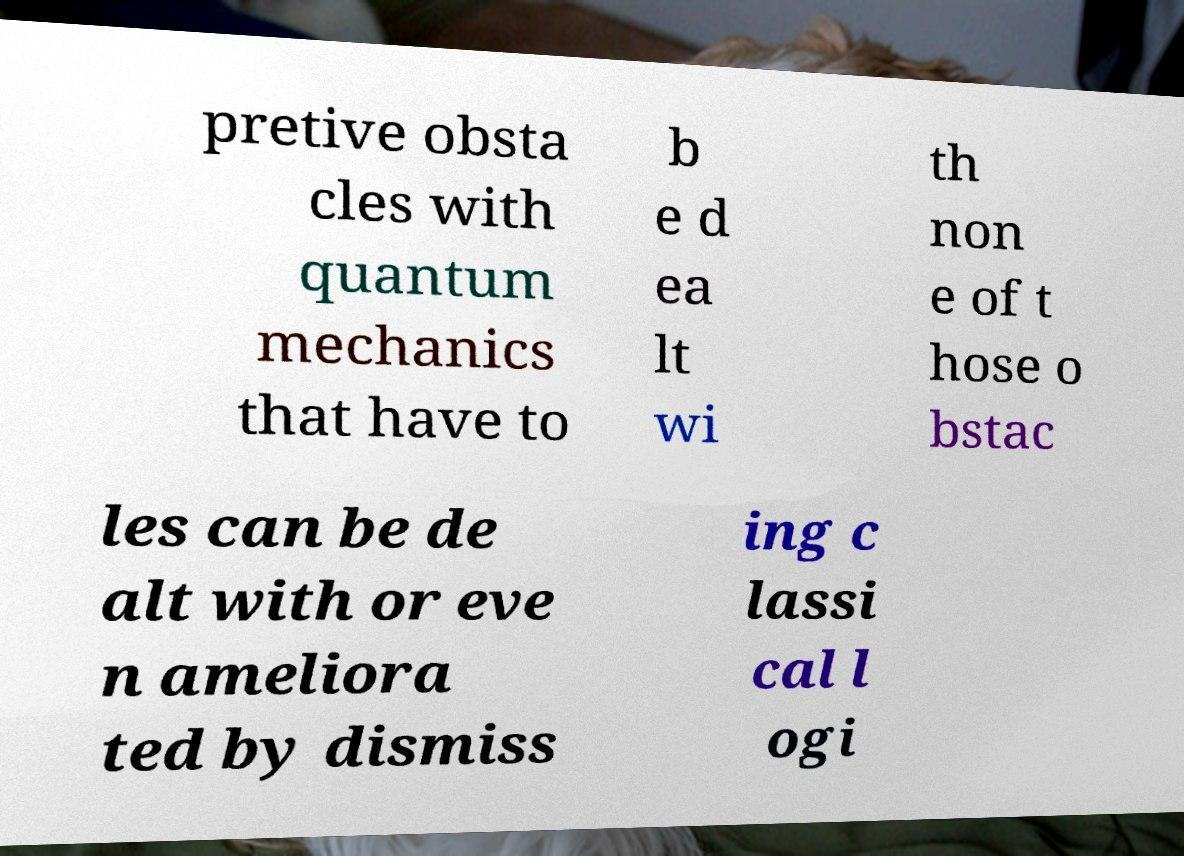Could you assist in decoding the text presented in this image and type it out clearly? pretive obsta cles with quantum mechanics that have to b e d ea lt wi th non e of t hose o bstac les can be de alt with or eve n ameliora ted by dismiss ing c lassi cal l ogi 